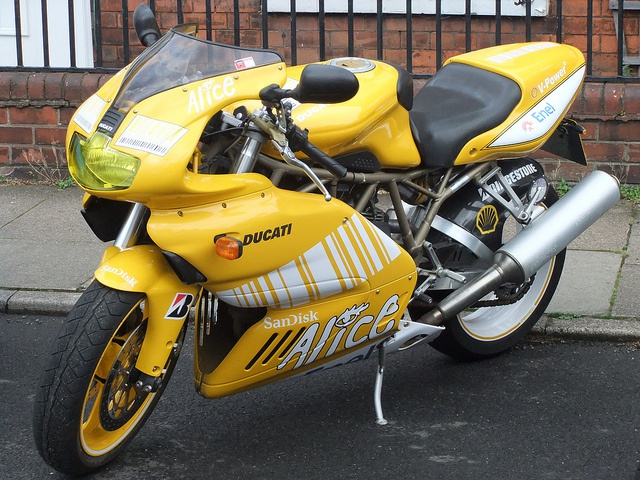Describe the objects in this image and their specific colors. I can see a motorcycle in lightgray, black, gray, white, and orange tones in this image. 